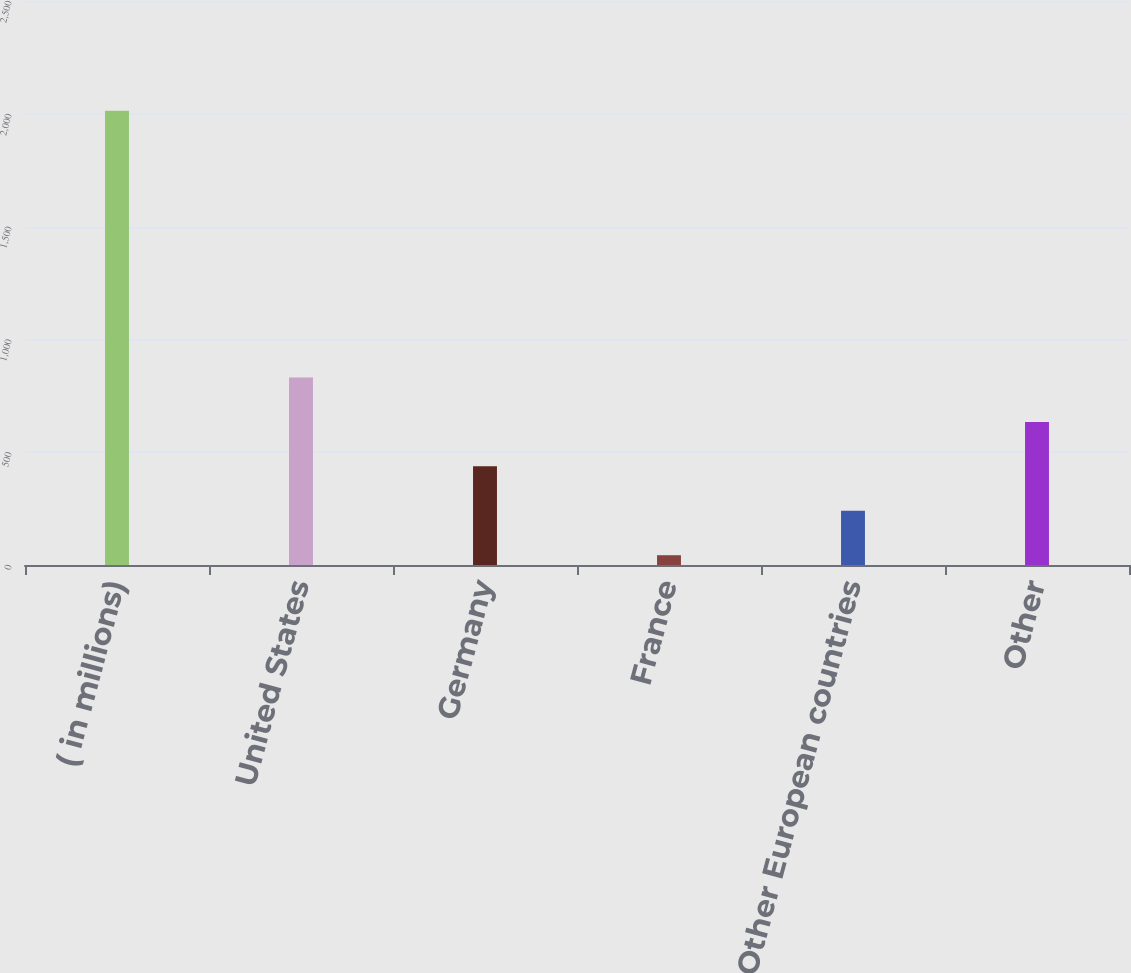Convert chart. <chart><loc_0><loc_0><loc_500><loc_500><bar_chart><fcel>( in millions)<fcel>United States<fcel>Germany<fcel>France<fcel>Other European countries<fcel>Other<nl><fcel>2013<fcel>831.24<fcel>437.32<fcel>43.4<fcel>240.36<fcel>634.28<nl></chart> 